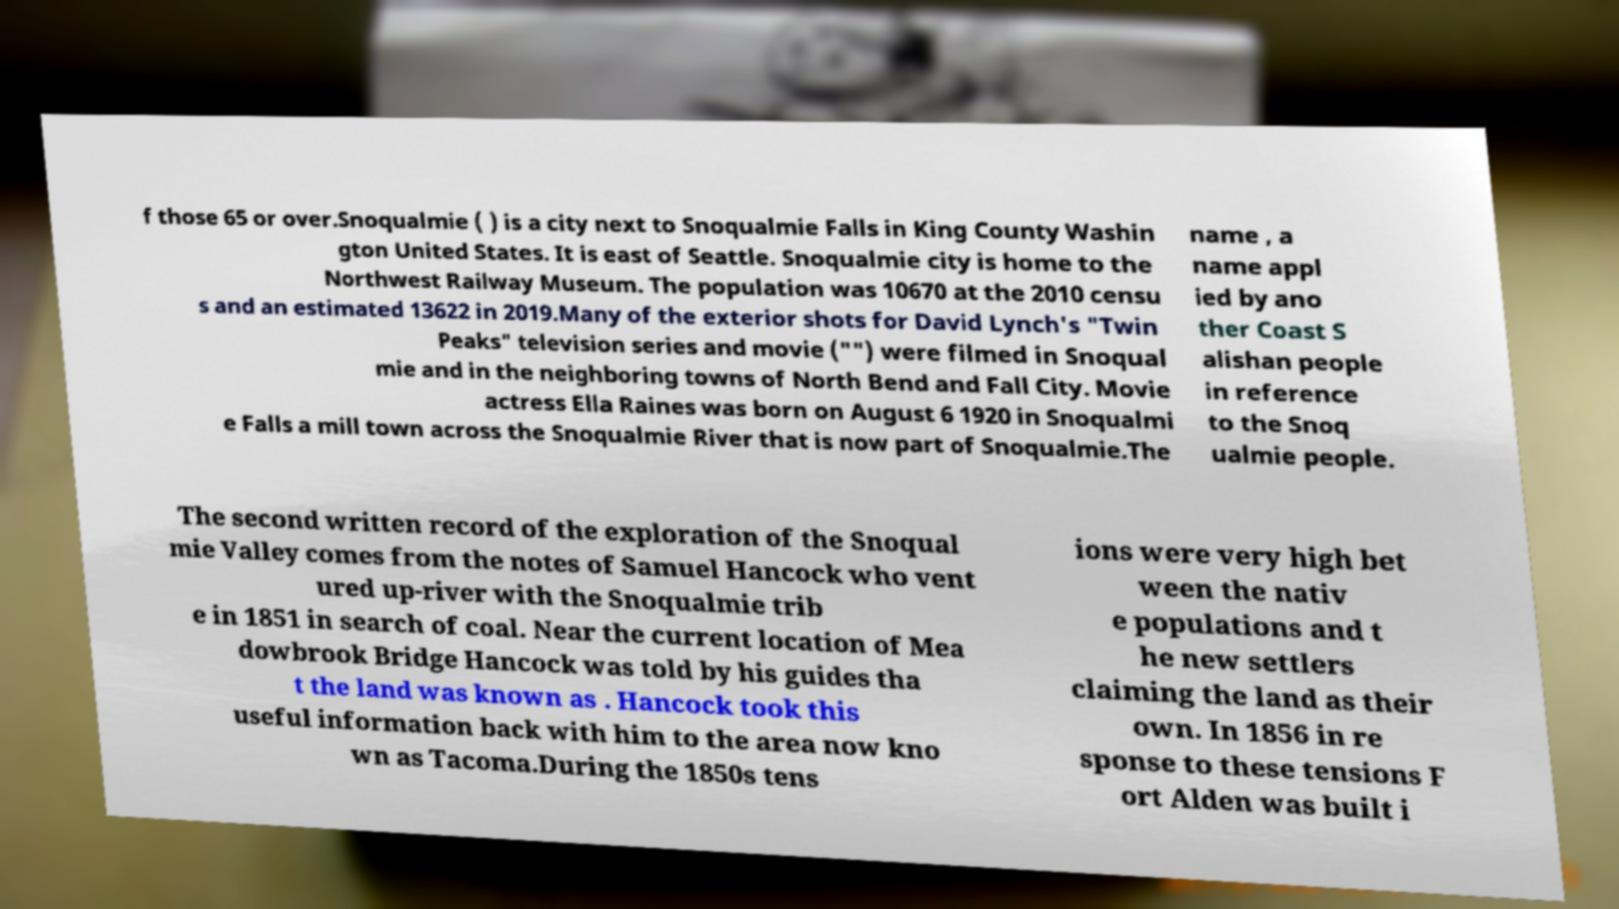I need the written content from this picture converted into text. Can you do that? f those 65 or over.Snoqualmie ( ) is a city next to Snoqualmie Falls in King County Washin gton United States. It is east of Seattle. Snoqualmie city is home to the Northwest Railway Museum. The population was 10670 at the 2010 censu s and an estimated 13622 in 2019.Many of the exterior shots for David Lynch's "Twin Peaks" television series and movie ("") were filmed in Snoqual mie and in the neighboring towns of North Bend and Fall City. Movie actress Ella Raines was born on August 6 1920 in Snoqualmi e Falls a mill town across the Snoqualmie River that is now part of Snoqualmie.The name , a name appl ied by ano ther Coast S alishan people in reference to the Snoq ualmie people. The second written record of the exploration of the Snoqual mie Valley comes from the notes of Samuel Hancock who vent ured up-river with the Snoqualmie trib e in 1851 in search of coal. Near the current location of Mea dowbrook Bridge Hancock was told by his guides tha t the land was known as . Hancock took this useful information back with him to the area now kno wn as Tacoma.During the 1850s tens ions were very high bet ween the nativ e populations and t he new settlers claiming the land as their own. In 1856 in re sponse to these tensions F ort Alden was built i 